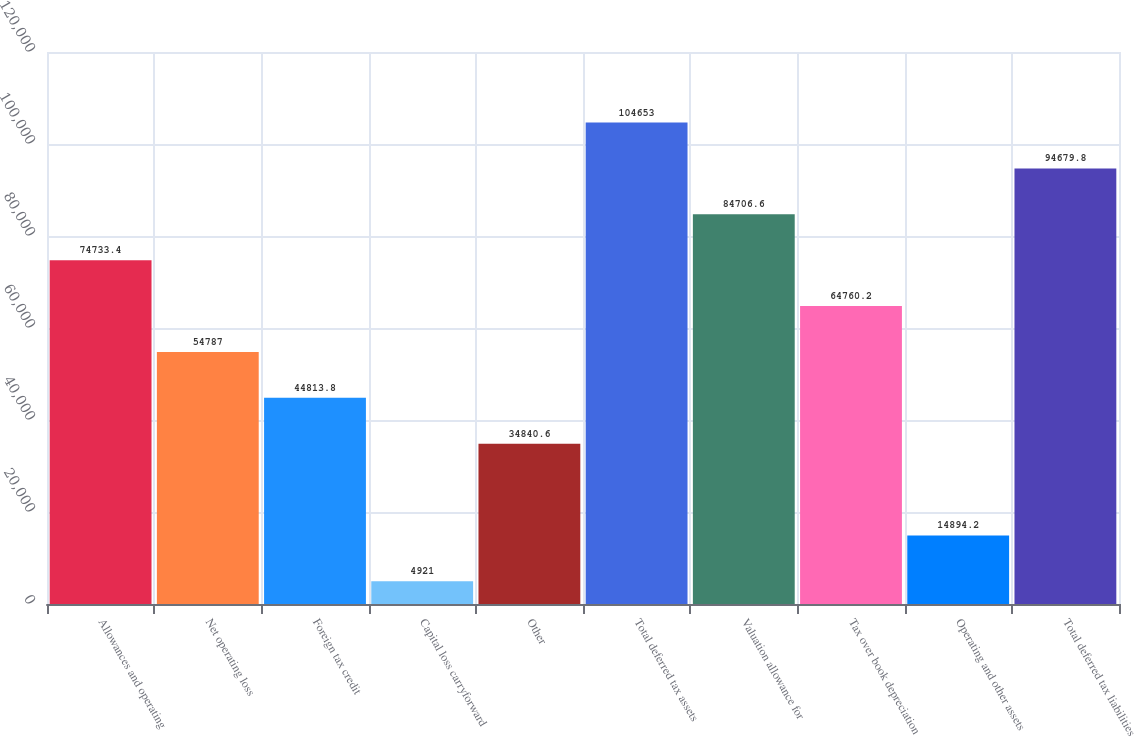Convert chart to OTSL. <chart><loc_0><loc_0><loc_500><loc_500><bar_chart><fcel>Allowances and operating<fcel>Net operating loss<fcel>Foreign tax credit<fcel>Capital loss carryforward<fcel>Other<fcel>Total deferred tax assets<fcel>Valuation allowance for<fcel>Tax over book depreciation<fcel>Operating and other assets<fcel>Total deferred tax liabilities<nl><fcel>74733.4<fcel>54787<fcel>44813.8<fcel>4921<fcel>34840.6<fcel>104653<fcel>84706.6<fcel>64760.2<fcel>14894.2<fcel>94679.8<nl></chart> 